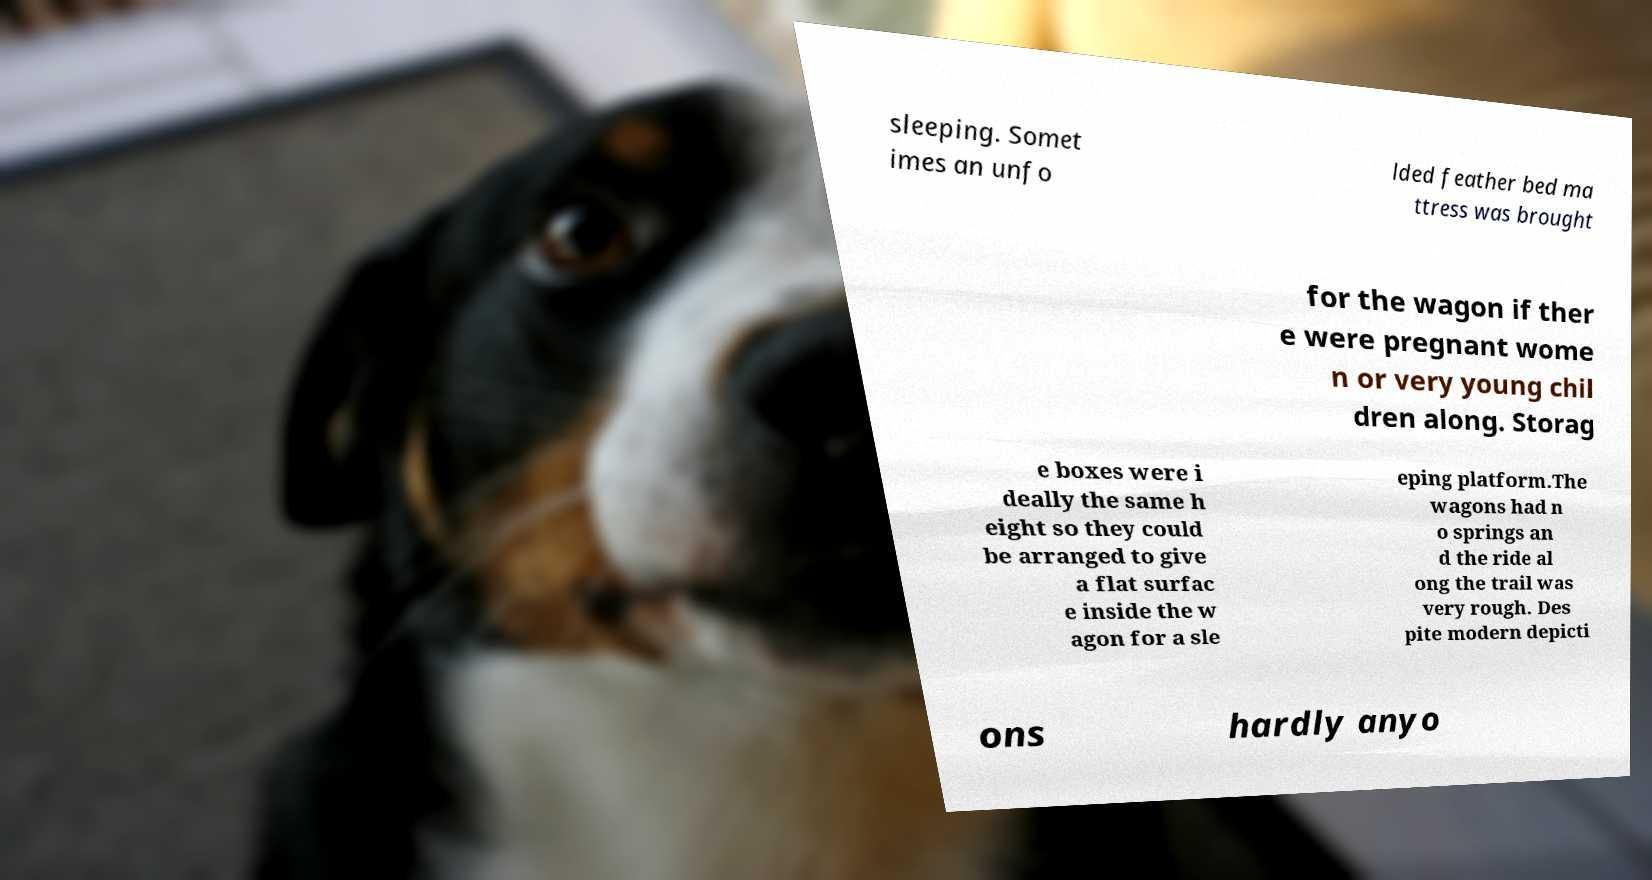Could you assist in decoding the text presented in this image and type it out clearly? sleeping. Somet imes an unfo lded feather bed ma ttress was brought for the wagon if ther e were pregnant wome n or very young chil dren along. Storag e boxes were i deally the same h eight so they could be arranged to give a flat surfac e inside the w agon for a sle eping platform.The wagons had n o springs an d the ride al ong the trail was very rough. Des pite modern depicti ons hardly anyo 